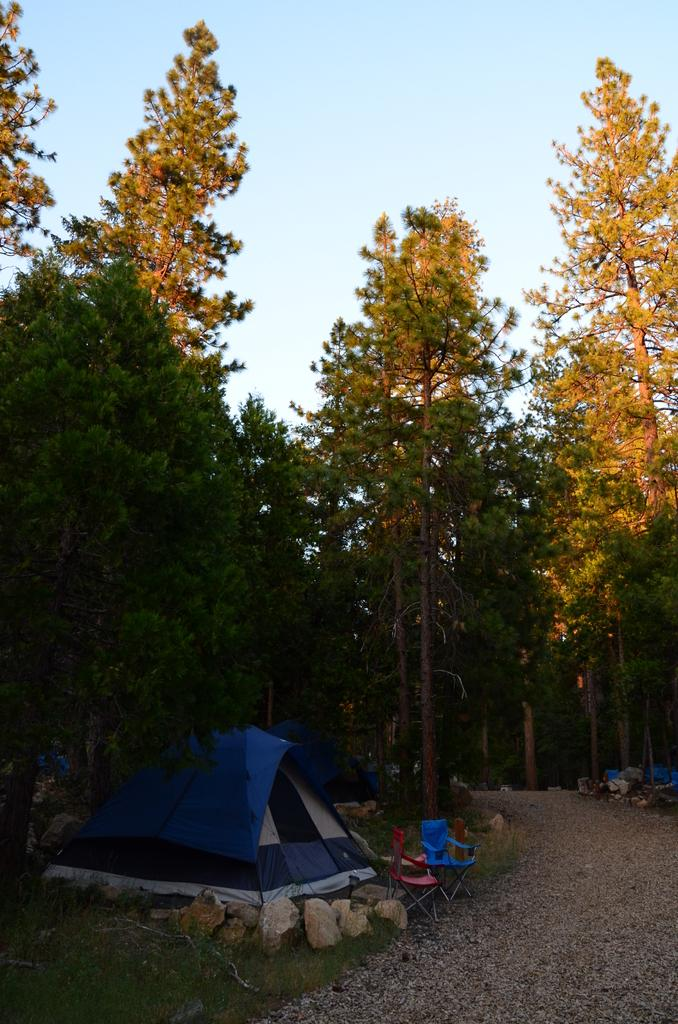What structure is located on the left side of the image? There is a tent on the left side of the image. What can be found on the ground near the tent? There are stones and two chairs on the ground on the left side of the image. What is visible on the right side of the image? There is a path on the right side of the image. What can be seen in the background of the image? There are trees and the sky visible in the background of the image. What type of poison is being used to treat the trees in the image? There is no mention of poison or any treatment for the trees in the image. Can you see a baseball game happening in the image? There is no mention of a baseball game or any sports activity in the image. --- Facts: 1. There is a person in the image. 2. The person is wearing a hat. 3. The person is holding a book. 4. The person is sitting on a bench. 5. There is a tree in the background of the image. Absurd Topics: unicorn, spaceship, alien Conversation: What is the main subject in the image? There is a person in the image. What is the person wearing? The person is wearing a hat. What is the person holding? The person is holding a book. What is the person doing? The person is sitting on a bench. What can be seen in the background of the image? There is a tree in the background of the image. Reasoning: Let's think step by step in order to ${produce the conversation}. We start by identifying the main subject of the image, which is the person. Next, we describe specific features of the person, such as the hat and the book they are holding. Then, we observe the actions of the person, noting that they are sitting on a bench. Finally, we describe the background of the image, which includes a tree. Absurd Question/Answer: What type of unicorn can be seen flying in the image? There is no unicorn present in the image. --- Facts: 1. There is a cat in the image. 2. The cat is sitting on a windowsill. 3. The cat is looking out the window. 4. There is a bird visible outside the window. 5. The windowsill has a potted plant on it. Absurd Topics: dinosaur, spacesuit, astronaut Conversation: What type of animal is in the image? There is a cat in the image. Where is the cat located? The cat is sitting on a windowsills. What is the cat doing? The cat is looking out the window. What can be seen outside the window? There is a bird visible outside the window. 